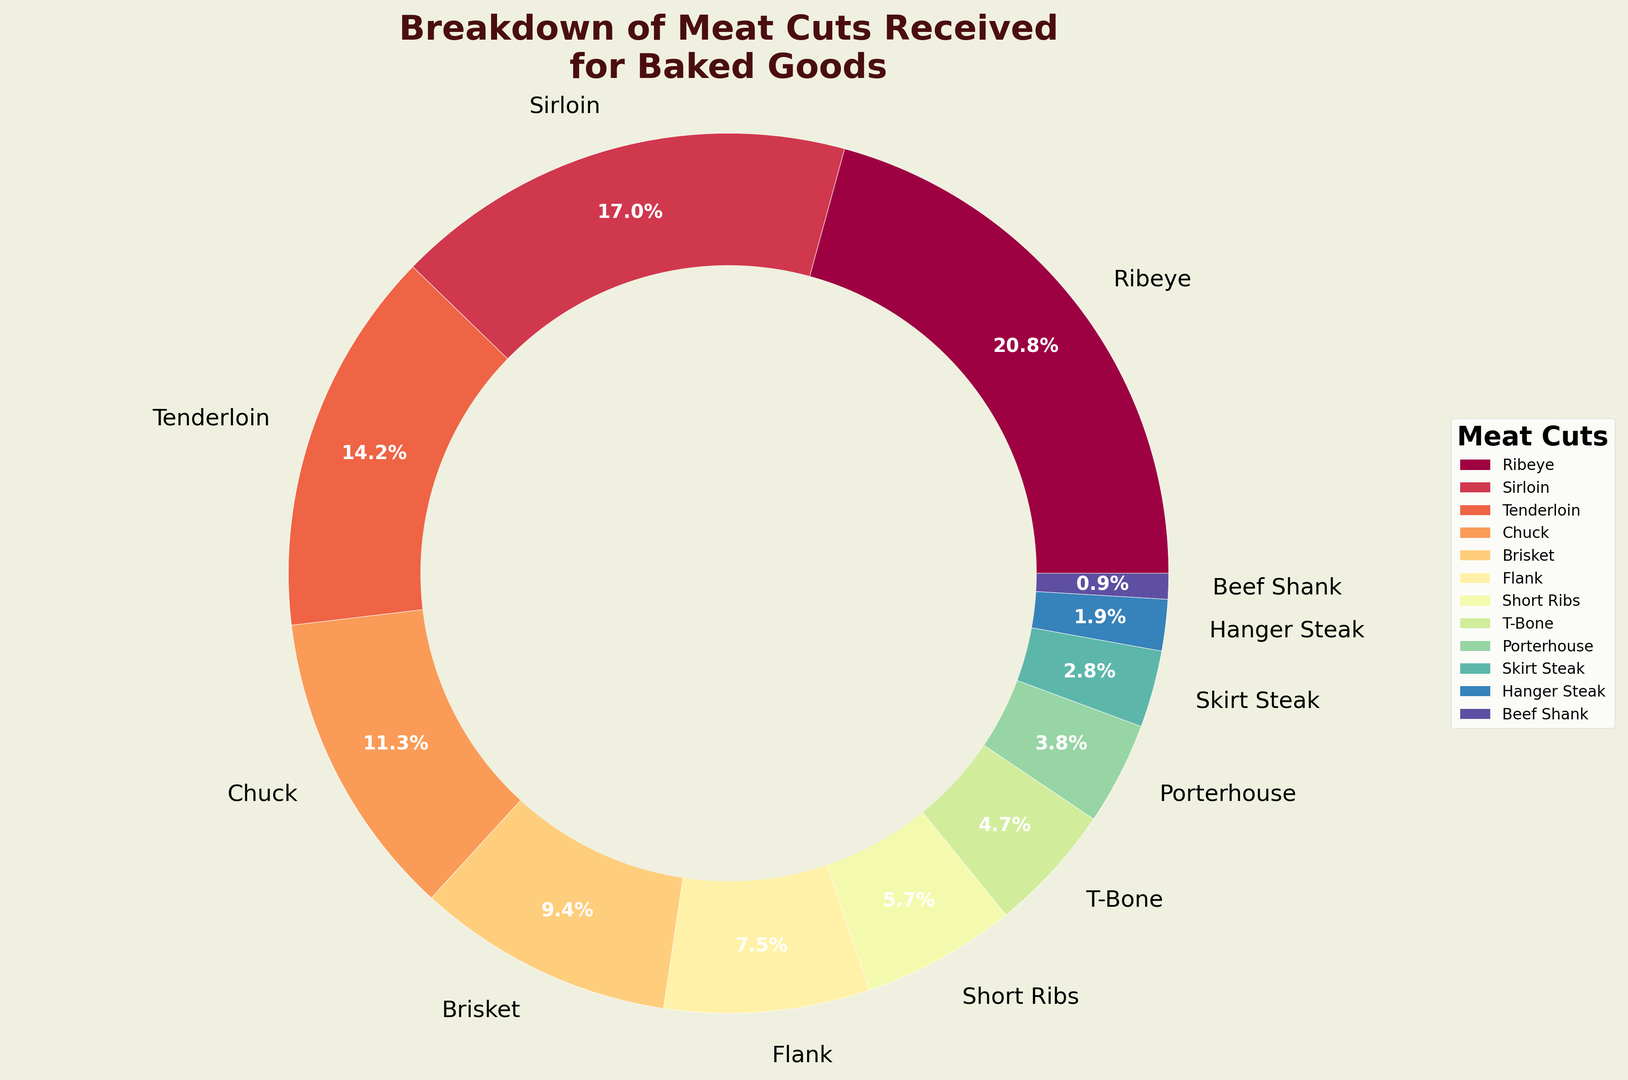Which meat cut has the highest percentage in the breakdown? The pie chart shows the Ribeye slice as the largest section with 22% clearly mentioned.
Answer: Ribeye Which meat cut has the lowest percentage? The chart shows Beef Shank as the smallest slice, indicated with a 1% label.
Answer: Beef Shank What is the combined percentage of Sirloin and Tenderloin? Sirloin has 18% and Tenderloin has 15%. Adding them up: 18% + 15% = 33%.
Answer: 33% Is there a meat cut with a percentage greater than 20%? If yes, which one? The chart shows Ribeye at 22%, which is greater than 20%.
Answer: Yes, Ribeye Are there more meat cuts with percentages below 10% than those above 10%? The cuts below 10% are Brisket, Flank, Short Ribs, T-Bone, Porterhouse, Skirt Steak, Hanger Steak, and Beef Shank (8 cuts). Those above 10% are Ribeye, Sirloin, Tenderloin, and Chuck (4 cuts).
Answer: Yes How many meat cuts have a percentage between 10% and 20%? The cuts within this range are Sirloin (18%), Tenderloin (15%), and Chuck (12%).
Answer: 3 What is the average percentage of Flank, Short Ribs, T-Bone, and Porterhouse combined? Adding these: 8% (Flank) + 6% (Short Ribs) + 5% (T-Bone) + 4% (Porterhouse) = 23%. Averaging: 23% / 4 = 5.75%.
Answer: 5.75% Which meat cut has a percentage closest to the median percentage value? List percentages in order: 1, 2, 3, 4, 5, 6, 8, 10, 12, 15, 18, 22. The median value (middle one) for 12 items is the average of the 6th and 7th values, i.e., (6 + 8)/2 = 7. Closest cut to 7% is Flank at 8%.
Answer: Flank Which two meat cuts together make up more than 35% of the bakery's exchanged goods? Ribeye (22%) and Sirloin (18%) combined are 22% + 18% = 40%, which is more than 35%.
Answer: Ribeye and Sirloin How many meat cuts belong to the color spectrum represented by the center-most wedge colors? The wedges closer to the center are Porterhouse (4%), Skirt Steak (3%), Hanger Steak (2%), and Beef Shank (1%).
Answer: 4 